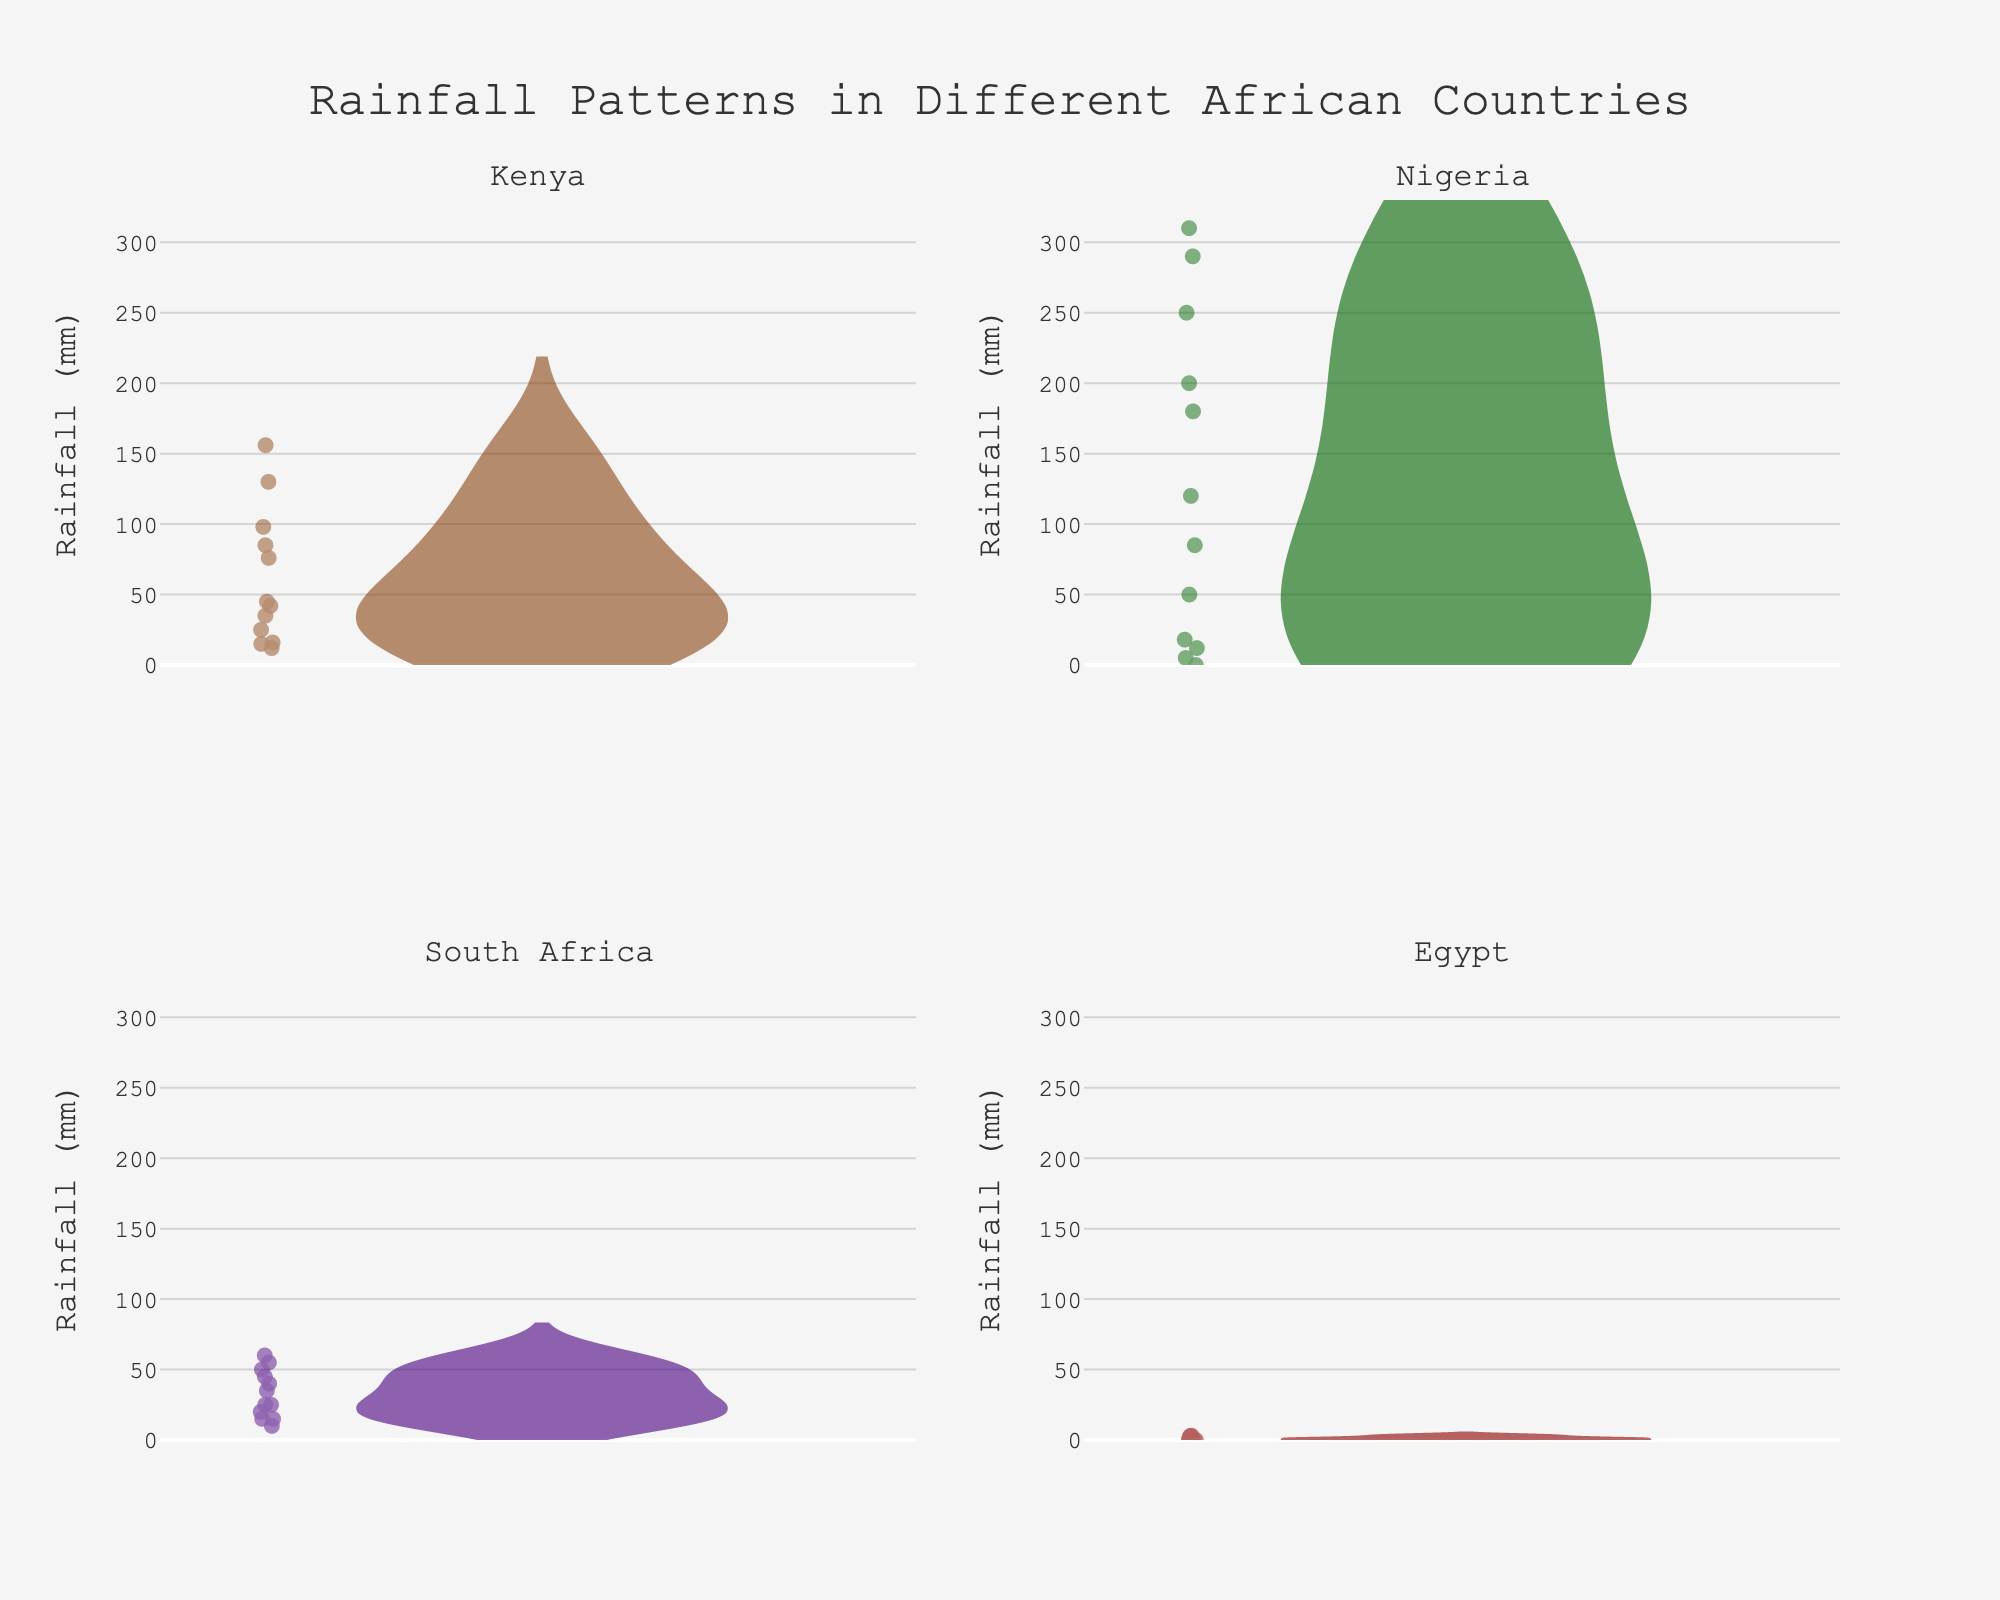What is the title of the plot? The title is located at the top of the figure and it summarizes the content of the plot.
Answer: Rainfall Patterns in Different African Countries Which country has the highest average rainfall? By looking at the violins, identify the one with the highest median line. Nigeria has the highest average rainfall because its median line is the highest among the four countries.
Answer: Nigeria Which country experiences the least rainfall overall throughout the year? Look at the width of the violins and the position of the mean and median lines. The country with the least rainfall throughout the year is Egypt, as it has the smallest violin plot and the lowest median rainfall.
Answer: Egypt For Kenya, what is the median monthly rainfall? Identify the median line in the Kenya violin plot. The median falls around halfway in the plot, indicating the central monthly rainfall value.
Answer: 45 mm Which two countries have the most similar rainfall patterns? Compare the overall shapes, widths, and medians of the violins. South Africa and Kenya have similar violin shapes and median rainfall values, suggesting similar rainfall patterns.
Answer: South Africa and Kenya How does the rainfall in Nigeria in August compare to the other months? Look at the points on the Nigeria violin plot. August has one of the highest peaks, indicating it receives significantly more rainfall compared to other months.
Answer: Highest In which month does South Africa experience the least rainfall? Look into the South Africa violin plot and find the smallest value point. The least rainfall in South Africa is observed in August.
Answer: August How does the maximum rainfall in South Africa compare to the maximum rainfall in Kenya? Identify the top points in both the South Africa and Kenya violin plots. The maximum rainfall in South Africa is observed in March (55mm), while in Kenya, it is in May (156mm), showing Kenya receives more maximum rainfall.
Answer: Kenya receives more What is the notable difference between the violins of Nigeria and Egypt? Compare the sizes and spreads of all data points. Nigeria has a wide range with a high peak indicating high variability and maximum rainfall, whereas Egypt has a very narrow range, indicating low and consistent low rainfall.
Answer: Nigeria has high variability and Egypt has low and consistent rainfall 